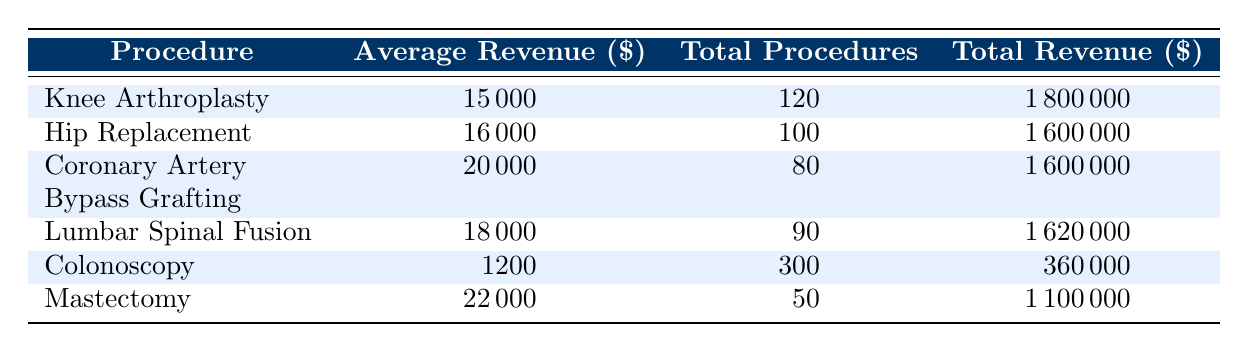What is the average revenue generated by Knee Arthroplasty? The table states that the average revenue for Knee Arthroplasty is 15000.
Answer: 15000 How many total procedures were conducted for Hip Replacement? The table lists the total procedures for Hip Replacement as 100.
Answer: 100 Is the total revenue from Lumbar Spinal Fusion higher than that from Colonoscopy? The total revenue from Lumbar Spinal Fusion is 1620000, while the total revenue from Colonoscopy is 360000. Since 1620000 is greater than 360000, the answer is yes.
Answer: Yes What is the total revenue generated by all procedure types combined? Calculating the total revenue involves summing the total revenues for each procedure: 1800000 + 1600000 + 1600000 + 1620000 + 360000 + 1100000 = 7240000.
Answer: 7240000 Which procedure generated the highest average revenue? Looking at the average revenues listed, Mastectomy has the highest revenue at 22000 compared to the others.
Answer: Mastectomy What is the difference in total revenue between Coronary Artery Bypass Grafting and Knee Arthroplasty? The total revenue for Coronary Artery Bypass Grafting is 1600000 and for Knee Arthroplasty it is 1800000. The difference is 1800000 - 1600000 = 200000.
Answer: 200000 Did Mastectomy have more total procedures than Knee Arthroplasty? Mastectomy had 50 total procedures, while Knee Arthroplasty had 120. Since 50 is less than 120, the answer is no.
Answer: No What is the average revenue across all procedure types? The average revenue can be calculated by summing all average revenues (15000 + 16000 + 20000 + 18000 + 1200 + 22000) and dividing by 6 (the number of procedures): (15000 + 16000 + 20000 + 18000 + 1200 + 22000) / 6 = 15500.
Answer: 15500 How does the average revenue from Colonoscopy compare to that of Hip Replacement? The average revenue for Colonoscopy is 1200, while for Hip Replacement it is 16000. Since 1200 is less than 16000, Colonoscopy has a lower average revenue.
Answer: Lower 